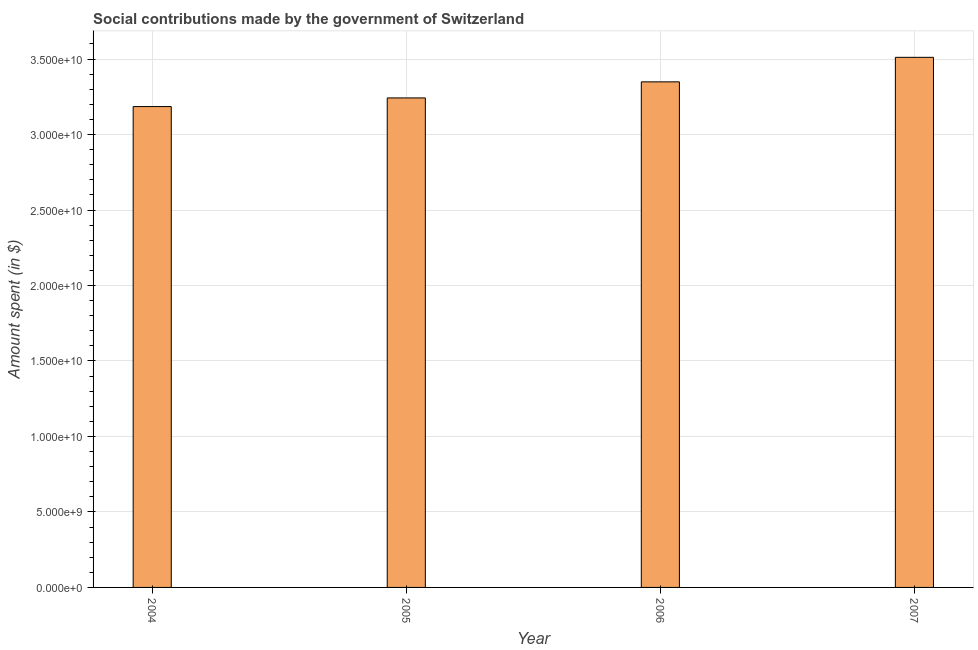What is the title of the graph?
Make the answer very short. Social contributions made by the government of Switzerland. What is the label or title of the Y-axis?
Your answer should be very brief. Amount spent (in $). What is the amount spent in making social contributions in 2005?
Provide a short and direct response. 3.24e+1. Across all years, what is the maximum amount spent in making social contributions?
Make the answer very short. 3.51e+1. Across all years, what is the minimum amount spent in making social contributions?
Provide a succinct answer. 3.19e+1. In which year was the amount spent in making social contributions maximum?
Your answer should be very brief. 2007. In which year was the amount spent in making social contributions minimum?
Offer a very short reply. 2004. What is the sum of the amount spent in making social contributions?
Your answer should be very brief. 1.33e+11. What is the difference between the amount spent in making social contributions in 2006 and 2007?
Give a very brief answer. -1.62e+09. What is the average amount spent in making social contributions per year?
Your answer should be compact. 3.32e+1. What is the median amount spent in making social contributions?
Ensure brevity in your answer.  3.30e+1. In how many years, is the amount spent in making social contributions greater than 9000000000 $?
Give a very brief answer. 4. Do a majority of the years between 2006 and 2004 (inclusive) have amount spent in making social contributions greater than 34000000000 $?
Give a very brief answer. Yes. What is the ratio of the amount spent in making social contributions in 2004 to that in 2006?
Your response must be concise. 0.95. What is the difference between the highest and the second highest amount spent in making social contributions?
Make the answer very short. 1.62e+09. What is the difference between the highest and the lowest amount spent in making social contributions?
Offer a terse response. 3.26e+09. In how many years, is the amount spent in making social contributions greater than the average amount spent in making social contributions taken over all years?
Your response must be concise. 2. How many bars are there?
Your answer should be compact. 4. Are all the bars in the graph horizontal?
Provide a succinct answer. No. How many years are there in the graph?
Make the answer very short. 4. What is the difference between two consecutive major ticks on the Y-axis?
Your answer should be compact. 5.00e+09. What is the Amount spent (in $) in 2004?
Make the answer very short. 3.19e+1. What is the Amount spent (in $) in 2005?
Provide a short and direct response. 3.24e+1. What is the Amount spent (in $) of 2006?
Offer a terse response. 3.35e+1. What is the Amount spent (in $) of 2007?
Make the answer very short. 3.51e+1. What is the difference between the Amount spent (in $) in 2004 and 2005?
Offer a terse response. -5.73e+08. What is the difference between the Amount spent (in $) in 2004 and 2006?
Make the answer very short. -1.64e+09. What is the difference between the Amount spent (in $) in 2004 and 2007?
Your response must be concise. -3.26e+09. What is the difference between the Amount spent (in $) in 2005 and 2006?
Your answer should be compact. -1.06e+09. What is the difference between the Amount spent (in $) in 2005 and 2007?
Keep it short and to the point. -2.69e+09. What is the difference between the Amount spent (in $) in 2006 and 2007?
Your answer should be very brief. -1.62e+09. What is the ratio of the Amount spent (in $) in 2004 to that in 2006?
Keep it short and to the point. 0.95. What is the ratio of the Amount spent (in $) in 2004 to that in 2007?
Keep it short and to the point. 0.91. What is the ratio of the Amount spent (in $) in 2005 to that in 2006?
Your answer should be compact. 0.97. What is the ratio of the Amount spent (in $) in 2005 to that in 2007?
Your response must be concise. 0.92. What is the ratio of the Amount spent (in $) in 2006 to that in 2007?
Your answer should be very brief. 0.95. 